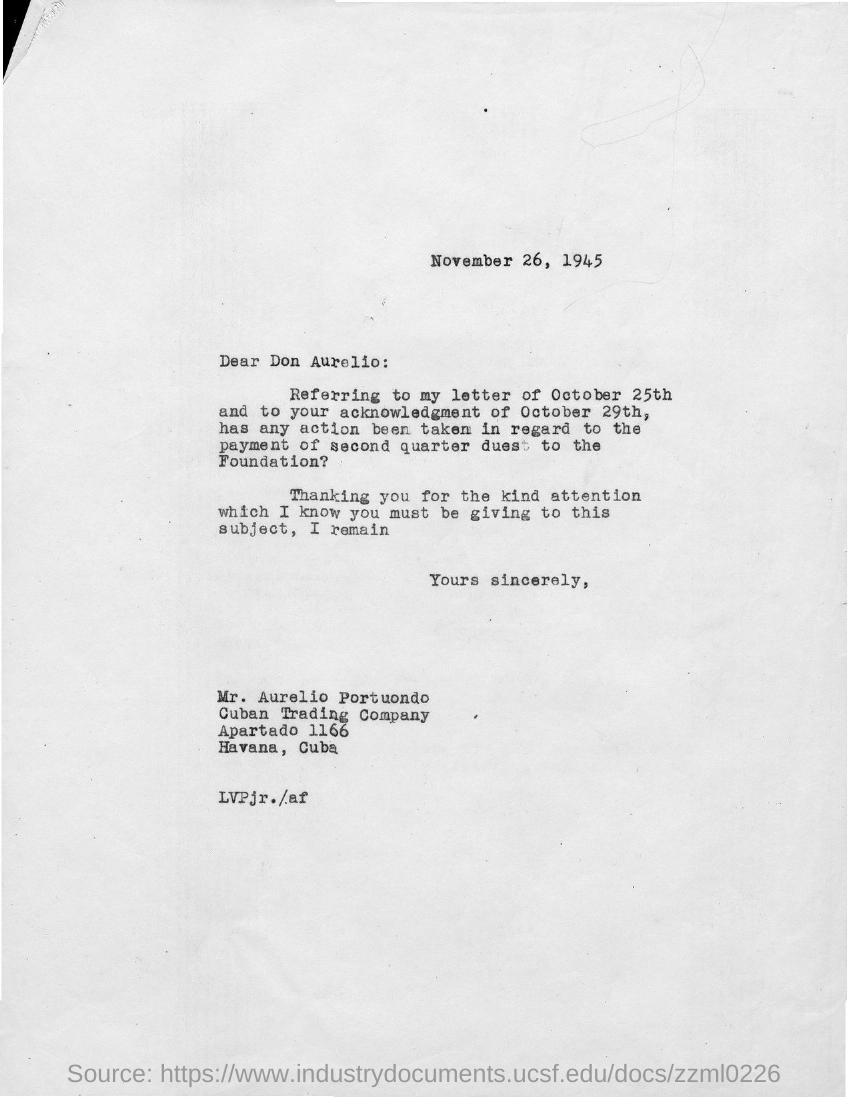When is the letter dated ?
Offer a very short reply. November 26, 1945. To whom is this letter written to?
Your answer should be very brief. Don aurelio. What is the street address of cuban trading company ?
Offer a terse response. Apartado 1166. 